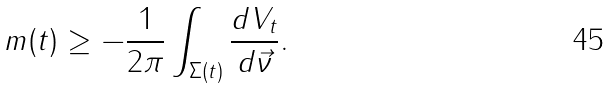Convert formula to latex. <formula><loc_0><loc_0><loc_500><loc_500>m ( t ) \geq - \frac { 1 } { 2 \pi } \int _ { \Sigma ( t ) } \frac { d V _ { t } } { d \vec { \nu } } .</formula> 